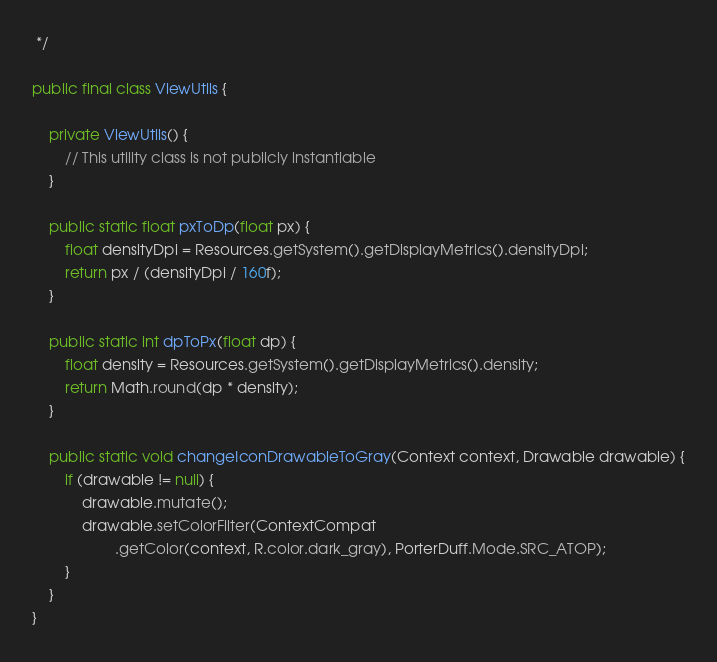Convert code to text. <code><loc_0><loc_0><loc_500><loc_500><_Java_> */

public final class ViewUtils {

    private ViewUtils() {
        // This utility class is not publicly instantiable
    }

    public static float pxToDp(float px) {
        float densityDpi = Resources.getSystem().getDisplayMetrics().densityDpi;
        return px / (densityDpi / 160f);
    }

    public static int dpToPx(float dp) {
        float density = Resources.getSystem().getDisplayMetrics().density;
        return Math.round(dp * density);
    }

    public static void changeIconDrawableToGray(Context context, Drawable drawable) {
        if (drawable != null) {
            drawable.mutate();
            drawable.setColorFilter(ContextCompat
                    .getColor(context, R.color.dark_gray), PorterDuff.Mode.SRC_ATOP);
        }
    }
}
</code> 